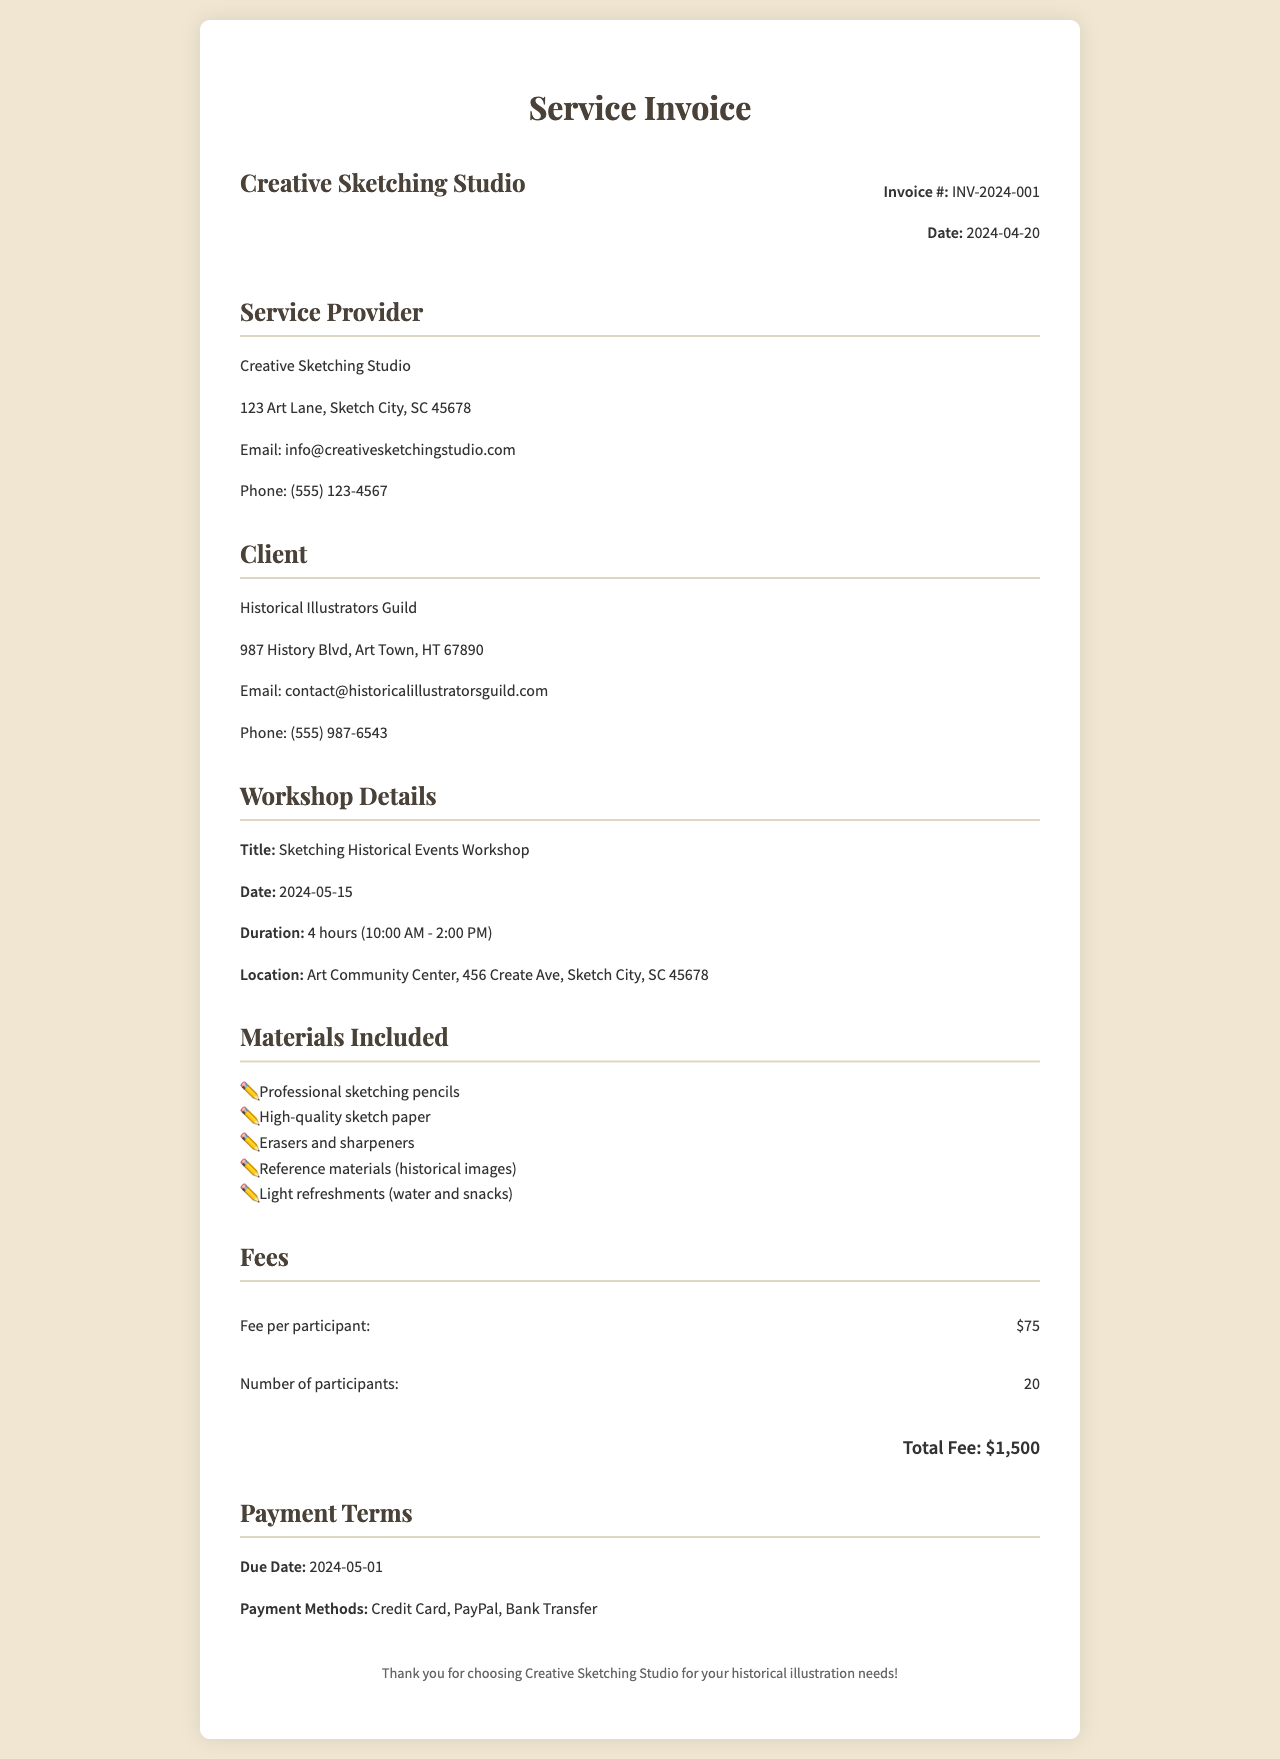What is the invoice number? The invoice number is listed at the top right section of the invoice document.
Answer: INV-2024-001 What is the date of the workshop? The date of the workshop is mentioned in the workshop details section.
Answer: 2024-05-15 Who is the service provider? The service provider's name is provided in the service provider section of the invoice.
Answer: Creative Sketching Studio How many participants are expected? The number of participants is specified in the fees section of the invoice.
Answer: 20 What is the total fee charged? The total fee is calculated based on the fee per participant and the number of participants.
Answer: $1,500 What materials are provided? The materials included are listed in the materials included section, specifying what participants receive.
Answer: Professional sketching pencils, High-quality sketch paper, Erasers and sharpeners, Reference materials, Light refreshments What are the payment methods? The payment methods available are mentioned in the payment terms section of the document.
Answer: Credit Card, PayPal, Bank Transfer How long is the workshop scheduled for? The duration of the workshop is stated in hours and is found in the workshop details section.
Answer: 4 hours When is the payment due? The due date for payment is specified in the payment terms section of the invoice.
Answer: 2024-05-01 